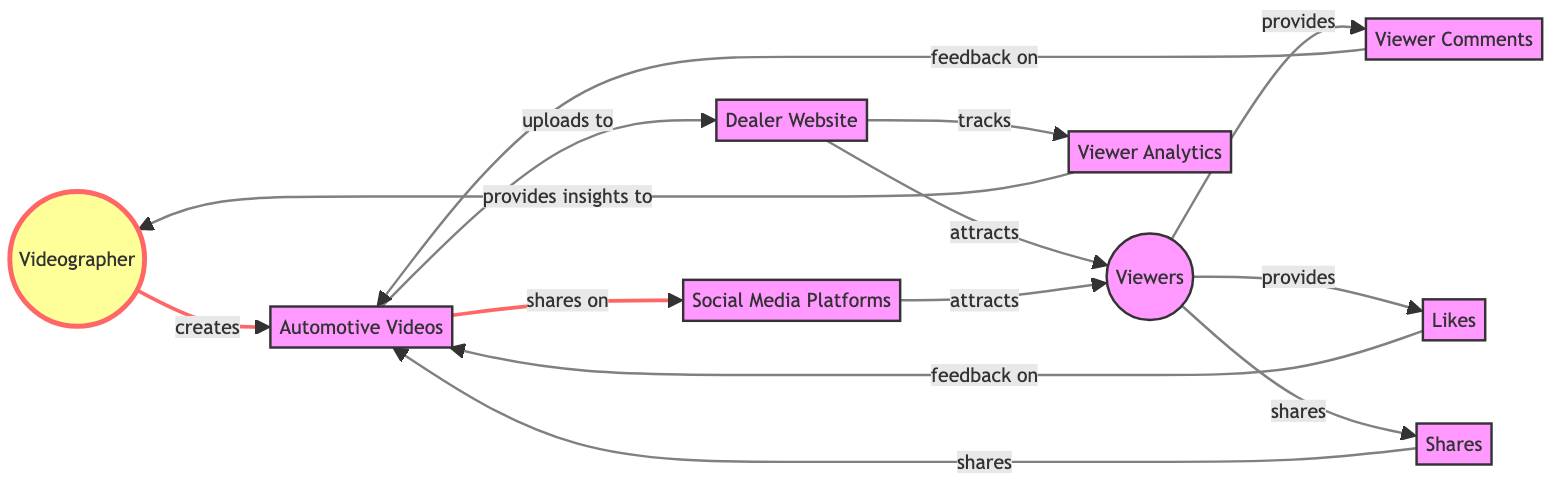What is the total number of nodes in the diagram? The diagram lists the following nodes: Videographer, Automotive Videos, Dealer Website, Viewers, Viewer Comments, Likes, Shares, Viewer Analytics, and Social Media Platforms, totaling 8 nodes.
Answer: 8 Which node provides insights to the Videographer? The arrow from Viewer Analytics to Videographer indicates that Viewer Analytics provides insights to the Videographer, making it the correct answer.
Answer: Viewer Analytics How many relationships does the Viewer have with other nodes? The Viewer node has connections to Viewer Comments, Likes, Shares, and attracts from Social Media Platforms, giving a total of 4 relationships.
Answer: 4 What is the relationship between Automotive Videos and Viewer Comments? The edge labeled "feedback on" connects Viewer Comments to Automotive Videos, indicating that Viewer Comments provide feedback on the Automotive Videos.
Answer: feedback on Which nodes are directly connected to the Dealer Website? The Dealer Website node is connected to Automotive Videos (uploads to) and Viewers (attracts), making them the nodes directly connected to it.
Answer: Automotive Videos, Viewers What type of feedback do Likes provide? Likes have an edge labeled "feedback on" leading to Automotive Videos, indicating that Likes provide feedback specifically on Automotive Videos.
Answer: feedback on What role do Social Media Platforms play in relation to Viewers? The Social Media Platforms attract Viewers, as indicated by the directed edge from Social Media Platforms to Viewers.
Answer: attracts How does the Videographer benefit from Viewer Analytics? Viewer Analytics tracks data regarding the interactions with videos on the Dealer Website, and these insights are provided to the Videographer, allowing them to understand viewer engagement.
Answer: provides insights to 